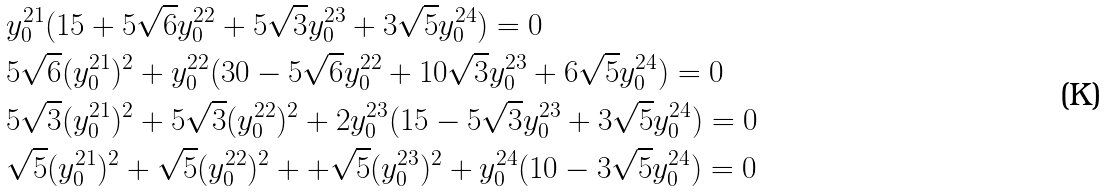Convert formula to latex. <formula><loc_0><loc_0><loc_500><loc_500>& y _ { 0 } ^ { 2 1 } ( 1 5 + 5 \sqrt { 6 } y _ { 0 } ^ { 2 2 } + 5 \sqrt { 3 } y _ { 0 } ^ { 2 3 } + 3 \sqrt { 5 } y _ { 0 } ^ { 2 4 } ) = 0 \\ & 5 \sqrt { 6 } ( y _ { 0 } ^ { 2 1 } ) ^ { 2 } + y _ { 0 } ^ { 2 2 } ( 3 0 - 5 \sqrt { 6 } y _ { 0 } ^ { 2 2 } + 1 0 \sqrt { 3 } y _ { 0 } ^ { 2 3 } + 6 \sqrt { 5 } y _ { 0 } ^ { 2 4 } ) = 0 \\ & 5 \sqrt { 3 } ( y _ { 0 } ^ { 2 1 } ) ^ { 2 } + 5 \sqrt { 3 } ( y _ { 0 } ^ { 2 2 } ) ^ { 2 } + 2 y _ { 0 } ^ { 2 3 } ( 1 5 - 5 \sqrt { 3 } y _ { 0 } ^ { 2 3 } + 3 \sqrt { 5 } y _ { 0 } ^ { 2 4 } ) = 0 \\ & \sqrt { 5 } ( y _ { 0 } ^ { 2 1 } ) ^ { 2 } + \sqrt { 5 } ( y _ { 0 } ^ { 2 2 } ) ^ { 2 } + + \sqrt { 5 } ( y _ { 0 } ^ { 2 3 } ) ^ { 2 } + y _ { 0 } ^ { 2 4 } ( 1 0 - 3 \sqrt { 5 } y _ { 0 } ^ { 2 4 } ) = 0</formula> 